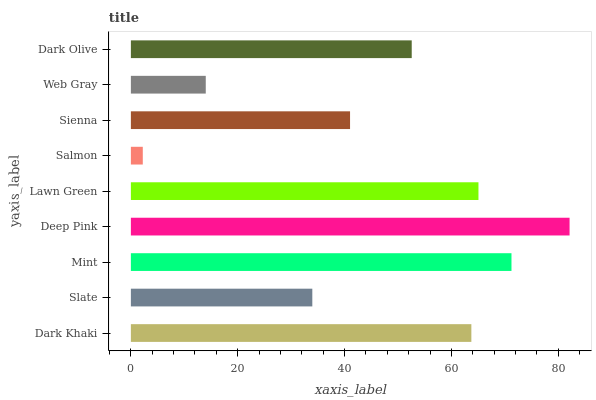Is Salmon the minimum?
Answer yes or no. Yes. Is Deep Pink the maximum?
Answer yes or no. Yes. Is Slate the minimum?
Answer yes or no. No. Is Slate the maximum?
Answer yes or no. No. Is Dark Khaki greater than Slate?
Answer yes or no. Yes. Is Slate less than Dark Khaki?
Answer yes or no. Yes. Is Slate greater than Dark Khaki?
Answer yes or no. No. Is Dark Khaki less than Slate?
Answer yes or no. No. Is Dark Olive the high median?
Answer yes or no. Yes. Is Dark Olive the low median?
Answer yes or no. Yes. Is Slate the high median?
Answer yes or no. No. Is Deep Pink the low median?
Answer yes or no. No. 